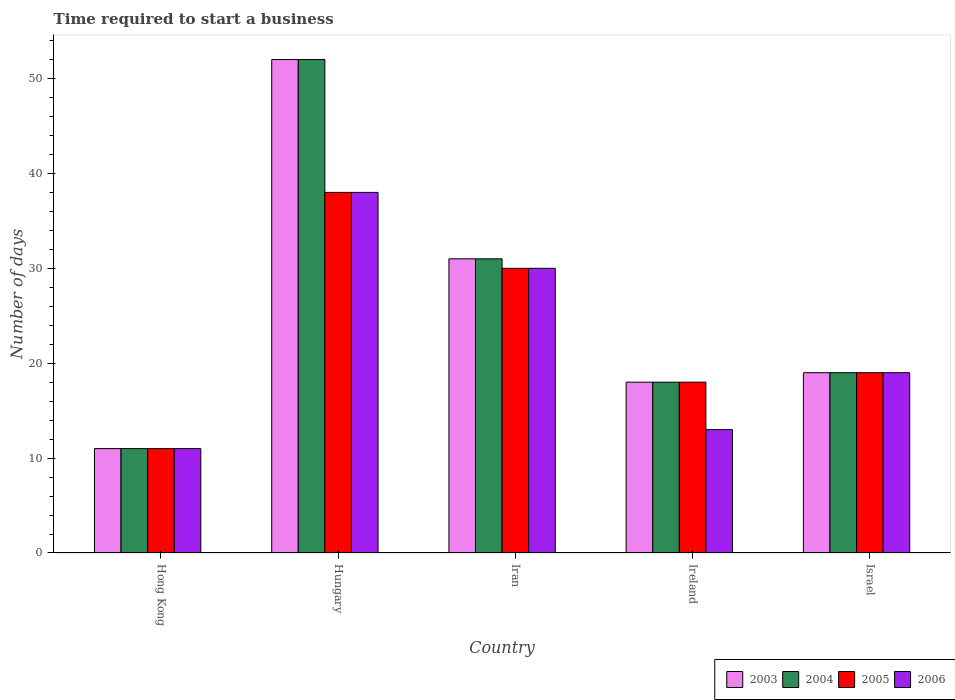How many groups of bars are there?
Your response must be concise. 5. Are the number of bars per tick equal to the number of legend labels?
Your answer should be compact. Yes. How many bars are there on the 5th tick from the left?
Your response must be concise. 4. How many bars are there on the 4th tick from the right?
Give a very brief answer. 4. What is the number of days required to start a business in 2006 in Israel?
Make the answer very short. 19. Across all countries, what is the maximum number of days required to start a business in 2005?
Provide a succinct answer. 38. Across all countries, what is the minimum number of days required to start a business in 2003?
Ensure brevity in your answer.  11. In which country was the number of days required to start a business in 2005 maximum?
Offer a terse response. Hungary. In which country was the number of days required to start a business in 2006 minimum?
Give a very brief answer. Hong Kong. What is the total number of days required to start a business in 2003 in the graph?
Your answer should be very brief. 131. What is the difference between the number of days required to start a business in 2005 in Israel and the number of days required to start a business in 2006 in Hong Kong?
Make the answer very short. 8. In how many countries, is the number of days required to start a business in 2003 greater than 6 days?
Give a very brief answer. 5. What is the ratio of the number of days required to start a business in 2006 in Hong Kong to that in Israel?
Offer a very short reply. 0.58. Is the number of days required to start a business in 2006 in Hungary less than that in Israel?
Ensure brevity in your answer.  No. In how many countries, is the number of days required to start a business in 2005 greater than the average number of days required to start a business in 2005 taken over all countries?
Provide a short and direct response. 2. Is the sum of the number of days required to start a business in 2003 in Iran and Ireland greater than the maximum number of days required to start a business in 2004 across all countries?
Give a very brief answer. No. Is it the case that in every country, the sum of the number of days required to start a business in 2004 and number of days required to start a business in 2003 is greater than the sum of number of days required to start a business in 2006 and number of days required to start a business in 2005?
Give a very brief answer. No. What does the 4th bar from the left in Hungary represents?
Provide a short and direct response. 2006. Is it the case that in every country, the sum of the number of days required to start a business in 2003 and number of days required to start a business in 2006 is greater than the number of days required to start a business in 2005?
Your answer should be very brief. Yes. How many bars are there?
Offer a terse response. 20. Are all the bars in the graph horizontal?
Make the answer very short. No. What is the difference between two consecutive major ticks on the Y-axis?
Offer a very short reply. 10. Does the graph contain any zero values?
Make the answer very short. No. Where does the legend appear in the graph?
Provide a succinct answer. Bottom right. How many legend labels are there?
Ensure brevity in your answer.  4. How are the legend labels stacked?
Keep it short and to the point. Horizontal. What is the title of the graph?
Provide a succinct answer. Time required to start a business. What is the label or title of the Y-axis?
Make the answer very short. Number of days. What is the Number of days of 2004 in Hong Kong?
Provide a short and direct response. 11. What is the Number of days in 2005 in Hong Kong?
Your answer should be very brief. 11. What is the Number of days in 2003 in Hungary?
Make the answer very short. 52. What is the Number of days in 2004 in Hungary?
Keep it short and to the point. 52. What is the Number of days of 2005 in Hungary?
Keep it short and to the point. 38. What is the Number of days of 2006 in Hungary?
Provide a short and direct response. 38. What is the Number of days of 2003 in Iran?
Your response must be concise. 31. What is the Number of days of 2004 in Iran?
Your answer should be very brief. 31. What is the Number of days of 2006 in Iran?
Your response must be concise. 30. What is the Number of days in 2004 in Ireland?
Ensure brevity in your answer.  18. What is the Number of days of 2006 in Ireland?
Provide a short and direct response. 13. What is the Number of days of 2006 in Israel?
Your response must be concise. 19. Across all countries, what is the maximum Number of days in 2003?
Offer a terse response. 52. Across all countries, what is the maximum Number of days in 2004?
Your answer should be compact. 52. Across all countries, what is the maximum Number of days of 2005?
Make the answer very short. 38. Across all countries, what is the maximum Number of days of 2006?
Your answer should be compact. 38. Across all countries, what is the minimum Number of days of 2003?
Offer a terse response. 11. Across all countries, what is the minimum Number of days in 2004?
Offer a terse response. 11. Across all countries, what is the minimum Number of days of 2006?
Your answer should be compact. 11. What is the total Number of days of 2003 in the graph?
Your answer should be very brief. 131. What is the total Number of days of 2004 in the graph?
Ensure brevity in your answer.  131. What is the total Number of days of 2005 in the graph?
Provide a short and direct response. 116. What is the total Number of days in 2006 in the graph?
Give a very brief answer. 111. What is the difference between the Number of days of 2003 in Hong Kong and that in Hungary?
Offer a terse response. -41. What is the difference between the Number of days in 2004 in Hong Kong and that in Hungary?
Give a very brief answer. -41. What is the difference between the Number of days of 2005 in Hong Kong and that in Hungary?
Your response must be concise. -27. What is the difference between the Number of days in 2003 in Hong Kong and that in Iran?
Ensure brevity in your answer.  -20. What is the difference between the Number of days in 2004 in Hong Kong and that in Iran?
Give a very brief answer. -20. What is the difference between the Number of days of 2005 in Hong Kong and that in Iran?
Your response must be concise. -19. What is the difference between the Number of days in 2006 in Hong Kong and that in Iran?
Provide a succinct answer. -19. What is the difference between the Number of days in 2004 in Hong Kong and that in Ireland?
Offer a terse response. -7. What is the difference between the Number of days of 2006 in Hong Kong and that in Ireland?
Offer a very short reply. -2. What is the difference between the Number of days in 2004 in Hong Kong and that in Israel?
Your answer should be compact. -8. What is the difference between the Number of days of 2005 in Hong Kong and that in Israel?
Make the answer very short. -8. What is the difference between the Number of days in 2006 in Hong Kong and that in Israel?
Provide a succinct answer. -8. What is the difference between the Number of days in 2003 in Hungary and that in Iran?
Give a very brief answer. 21. What is the difference between the Number of days in 2004 in Hungary and that in Iran?
Offer a very short reply. 21. What is the difference between the Number of days in 2005 in Hungary and that in Iran?
Your answer should be very brief. 8. What is the difference between the Number of days in 2003 in Hungary and that in Ireland?
Offer a very short reply. 34. What is the difference between the Number of days in 2005 in Hungary and that in Ireland?
Offer a terse response. 20. What is the difference between the Number of days of 2006 in Hungary and that in Ireland?
Your answer should be compact. 25. What is the difference between the Number of days of 2004 in Hungary and that in Israel?
Make the answer very short. 33. What is the difference between the Number of days of 2006 in Hungary and that in Israel?
Keep it short and to the point. 19. What is the difference between the Number of days in 2003 in Iran and that in Ireland?
Your answer should be very brief. 13. What is the difference between the Number of days of 2004 in Iran and that in Ireland?
Offer a terse response. 13. What is the difference between the Number of days in 2005 in Iran and that in Ireland?
Your answer should be very brief. 12. What is the difference between the Number of days in 2006 in Iran and that in Ireland?
Your answer should be compact. 17. What is the difference between the Number of days in 2004 in Iran and that in Israel?
Provide a short and direct response. 12. What is the difference between the Number of days in 2005 in Iran and that in Israel?
Offer a terse response. 11. What is the difference between the Number of days in 2006 in Ireland and that in Israel?
Your answer should be very brief. -6. What is the difference between the Number of days of 2003 in Hong Kong and the Number of days of 2004 in Hungary?
Offer a very short reply. -41. What is the difference between the Number of days in 2003 in Hong Kong and the Number of days in 2005 in Hungary?
Your response must be concise. -27. What is the difference between the Number of days in 2003 in Hong Kong and the Number of days in 2006 in Hungary?
Your answer should be compact. -27. What is the difference between the Number of days of 2004 in Hong Kong and the Number of days of 2006 in Hungary?
Offer a terse response. -27. What is the difference between the Number of days of 2003 in Hong Kong and the Number of days of 2004 in Iran?
Your answer should be very brief. -20. What is the difference between the Number of days in 2004 in Hong Kong and the Number of days in 2006 in Iran?
Offer a very short reply. -19. What is the difference between the Number of days of 2005 in Hong Kong and the Number of days of 2006 in Iran?
Ensure brevity in your answer.  -19. What is the difference between the Number of days of 2003 in Hong Kong and the Number of days of 2004 in Ireland?
Your response must be concise. -7. What is the difference between the Number of days of 2003 in Hong Kong and the Number of days of 2005 in Ireland?
Give a very brief answer. -7. What is the difference between the Number of days of 2005 in Hong Kong and the Number of days of 2006 in Ireland?
Keep it short and to the point. -2. What is the difference between the Number of days of 2003 in Hong Kong and the Number of days of 2004 in Israel?
Keep it short and to the point. -8. What is the difference between the Number of days of 2003 in Hong Kong and the Number of days of 2006 in Israel?
Offer a terse response. -8. What is the difference between the Number of days in 2004 in Hong Kong and the Number of days in 2006 in Israel?
Give a very brief answer. -8. What is the difference between the Number of days of 2005 in Hong Kong and the Number of days of 2006 in Israel?
Make the answer very short. -8. What is the difference between the Number of days in 2003 in Hungary and the Number of days in 2004 in Iran?
Offer a very short reply. 21. What is the difference between the Number of days in 2005 in Hungary and the Number of days in 2006 in Iran?
Give a very brief answer. 8. What is the difference between the Number of days in 2004 in Hungary and the Number of days in 2005 in Ireland?
Offer a very short reply. 34. What is the difference between the Number of days in 2004 in Hungary and the Number of days in 2006 in Ireland?
Offer a very short reply. 39. What is the difference between the Number of days in 2003 in Hungary and the Number of days in 2005 in Israel?
Provide a succinct answer. 33. What is the difference between the Number of days of 2004 in Hungary and the Number of days of 2005 in Israel?
Give a very brief answer. 33. What is the difference between the Number of days of 2004 in Hungary and the Number of days of 2006 in Israel?
Your answer should be very brief. 33. What is the difference between the Number of days of 2003 in Iran and the Number of days of 2005 in Ireland?
Your response must be concise. 13. What is the difference between the Number of days in 2004 in Iran and the Number of days in 2005 in Ireland?
Offer a very short reply. 13. What is the difference between the Number of days in 2005 in Iran and the Number of days in 2006 in Ireland?
Your answer should be compact. 17. What is the difference between the Number of days in 2003 in Iran and the Number of days in 2006 in Israel?
Keep it short and to the point. 12. What is the difference between the Number of days in 2004 in Iran and the Number of days in 2005 in Israel?
Keep it short and to the point. 12. What is the difference between the Number of days in 2005 in Iran and the Number of days in 2006 in Israel?
Offer a terse response. 11. What is the difference between the Number of days in 2003 in Ireland and the Number of days in 2004 in Israel?
Provide a succinct answer. -1. What is the difference between the Number of days in 2004 in Ireland and the Number of days in 2005 in Israel?
Your answer should be very brief. -1. What is the difference between the Number of days in 2004 in Ireland and the Number of days in 2006 in Israel?
Your answer should be very brief. -1. What is the average Number of days in 2003 per country?
Offer a very short reply. 26.2. What is the average Number of days of 2004 per country?
Offer a very short reply. 26.2. What is the average Number of days of 2005 per country?
Your response must be concise. 23.2. What is the average Number of days in 2006 per country?
Your answer should be compact. 22.2. What is the difference between the Number of days in 2003 and Number of days in 2004 in Hong Kong?
Offer a very short reply. 0. What is the difference between the Number of days in 2003 and Number of days in 2005 in Hong Kong?
Provide a succinct answer. 0. What is the difference between the Number of days in 2003 and Number of days in 2006 in Hong Kong?
Keep it short and to the point. 0. What is the difference between the Number of days of 2003 and Number of days of 2006 in Hungary?
Give a very brief answer. 14. What is the difference between the Number of days of 2004 and Number of days of 2006 in Hungary?
Your answer should be compact. 14. What is the difference between the Number of days of 2003 and Number of days of 2005 in Iran?
Keep it short and to the point. 1. What is the difference between the Number of days in 2003 and Number of days in 2006 in Iran?
Provide a succinct answer. 1. What is the difference between the Number of days of 2004 and Number of days of 2005 in Iran?
Provide a short and direct response. 1. What is the difference between the Number of days of 2004 and Number of days of 2006 in Iran?
Your response must be concise. 1. What is the difference between the Number of days in 2005 and Number of days in 2006 in Iran?
Provide a succinct answer. 0. What is the difference between the Number of days in 2003 and Number of days in 2005 in Ireland?
Give a very brief answer. 0. What is the difference between the Number of days in 2003 and Number of days in 2006 in Israel?
Make the answer very short. 0. What is the difference between the Number of days in 2005 and Number of days in 2006 in Israel?
Offer a terse response. 0. What is the ratio of the Number of days of 2003 in Hong Kong to that in Hungary?
Ensure brevity in your answer.  0.21. What is the ratio of the Number of days in 2004 in Hong Kong to that in Hungary?
Your answer should be compact. 0.21. What is the ratio of the Number of days of 2005 in Hong Kong to that in Hungary?
Ensure brevity in your answer.  0.29. What is the ratio of the Number of days in 2006 in Hong Kong to that in Hungary?
Provide a short and direct response. 0.29. What is the ratio of the Number of days of 2003 in Hong Kong to that in Iran?
Make the answer very short. 0.35. What is the ratio of the Number of days in 2004 in Hong Kong to that in Iran?
Make the answer very short. 0.35. What is the ratio of the Number of days of 2005 in Hong Kong to that in Iran?
Provide a succinct answer. 0.37. What is the ratio of the Number of days in 2006 in Hong Kong to that in Iran?
Your response must be concise. 0.37. What is the ratio of the Number of days in 2003 in Hong Kong to that in Ireland?
Your answer should be very brief. 0.61. What is the ratio of the Number of days in 2004 in Hong Kong to that in Ireland?
Make the answer very short. 0.61. What is the ratio of the Number of days of 2005 in Hong Kong to that in Ireland?
Offer a terse response. 0.61. What is the ratio of the Number of days in 2006 in Hong Kong to that in Ireland?
Keep it short and to the point. 0.85. What is the ratio of the Number of days of 2003 in Hong Kong to that in Israel?
Offer a very short reply. 0.58. What is the ratio of the Number of days of 2004 in Hong Kong to that in Israel?
Make the answer very short. 0.58. What is the ratio of the Number of days in 2005 in Hong Kong to that in Israel?
Give a very brief answer. 0.58. What is the ratio of the Number of days of 2006 in Hong Kong to that in Israel?
Your answer should be very brief. 0.58. What is the ratio of the Number of days of 2003 in Hungary to that in Iran?
Give a very brief answer. 1.68. What is the ratio of the Number of days of 2004 in Hungary to that in Iran?
Give a very brief answer. 1.68. What is the ratio of the Number of days in 2005 in Hungary to that in Iran?
Offer a terse response. 1.27. What is the ratio of the Number of days in 2006 in Hungary to that in Iran?
Provide a short and direct response. 1.27. What is the ratio of the Number of days in 2003 in Hungary to that in Ireland?
Your answer should be very brief. 2.89. What is the ratio of the Number of days of 2004 in Hungary to that in Ireland?
Keep it short and to the point. 2.89. What is the ratio of the Number of days in 2005 in Hungary to that in Ireland?
Ensure brevity in your answer.  2.11. What is the ratio of the Number of days in 2006 in Hungary to that in Ireland?
Make the answer very short. 2.92. What is the ratio of the Number of days in 2003 in Hungary to that in Israel?
Offer a very short reply. 2.74. What is the ratio of the Number of days of 2004 in Hungary to that in Israel?
Keep it short and to the point. 2.74. What is the ratio of the Number of days of 2005 in Hungary to that in Israel?
Offer a terse response. 2. What is the ratio of the Number of days in 2006 in Hungary to that in Israel?
Offer a very short reply. 2. What is the ratio of the Number of days of 2003 in Iran to that in Ireland?
Keep it short and to the point. 1.72. What is the ratio of the Number of days of 2004 in Iran to that in Ireland?
Make the answer very short. 1.72. What is the ratio of the Number of days in 2005 in Iran to that in Ireland?
Your answer should be compact. 1.67. What is the ratio of the Number of days in 2006 in Iran to that in Ireland?
Your answer should be very brief. 2.31. What is the ratio of the Number of days of 2003 in Iran to that in Israel?
Provide a short and direct response. 1.63. What is the ratio of the Number of days of 2004 in Iran to that in Israel?
Make the answer very short. 1.63. What is the ratio of the Number of days of 2005 in Iran to that in Israel?
Offer a terse response. 1.58. What is the ratio of the Number of days of 2006 in Iran to that in Israel?
Your response must be concise. 1.58. What is the ratio of the Number of days of 2004 in Ireland to that in Israel?
Provide a short and direct response. 0.95. What is the ratio of the Number of days of 2006 in Ireland to that in Israel?
Your answer should be compact. 0.68. What is the difference between the highest and the second highest Number of days of 2003?
Make the answer very short. 21. What is the difference between the highest and the second highest Number of days of 2004?
Your answer should be compact. 21. What is the difference between the highest and the lowest Number of days in 2004?
Make the answer very short. 41. What is the difference between the highest and the lowest Number of days of 2005?
Provide a succinct answer. 27. What is the difference between the highest and the lowest Number of days of 2006?
Provide a short and direct response. 27. 